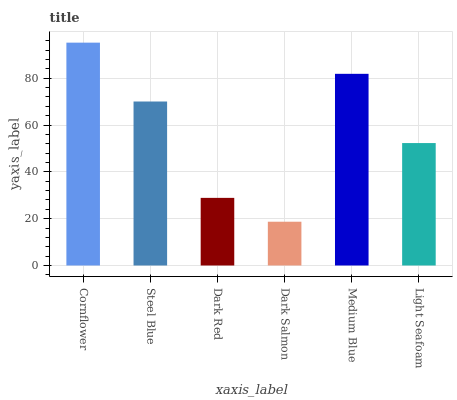Is Dark Salmon the minimum?
Answer yes or no. Yes. Is Cornflower the maximum?
Answer yes or no. Yes. Is Steel Blue the minimum?
Answer yes or no. No. Is Steel Blue the maximum?
Answer yes or no. No. Is Cornflower greater than Steel Blue?
Answer yes or no. Yes. Is Steel Blue less than Cornflower?
Answer yes or no. Yes. Is Steel Blue greater than Cornflower?
Answer yes or no. No. Is Cornflower less than Steel Blue?
Answer yes or no. No. Is Steel Blue the high median?
Answer yes or no. Yes. Is Light Seafoam the low median?
Answer yes or no. Yes. Is Cornflower the high median?
Answer yes or no. No. Is Dark Salmon the low median?
Answer yes or no. No. 